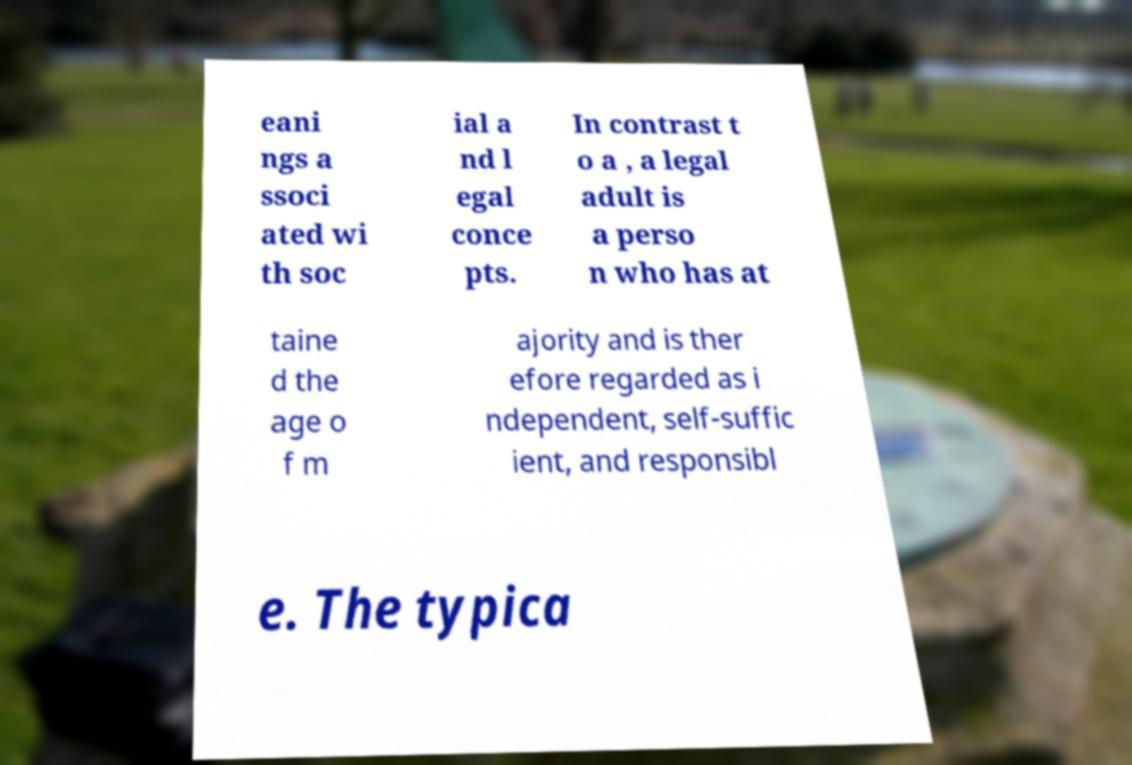Could you extract and type out the text from this image? eani ngs a ssoci ated wi th soc ial a nd l egal conce pts. In contrast t o a , a legal adult is a perso n who has at taine d the age o f m ajority and is ther efore regarded as i ndependent, self-suffic ient, and responsibl e. The typica 